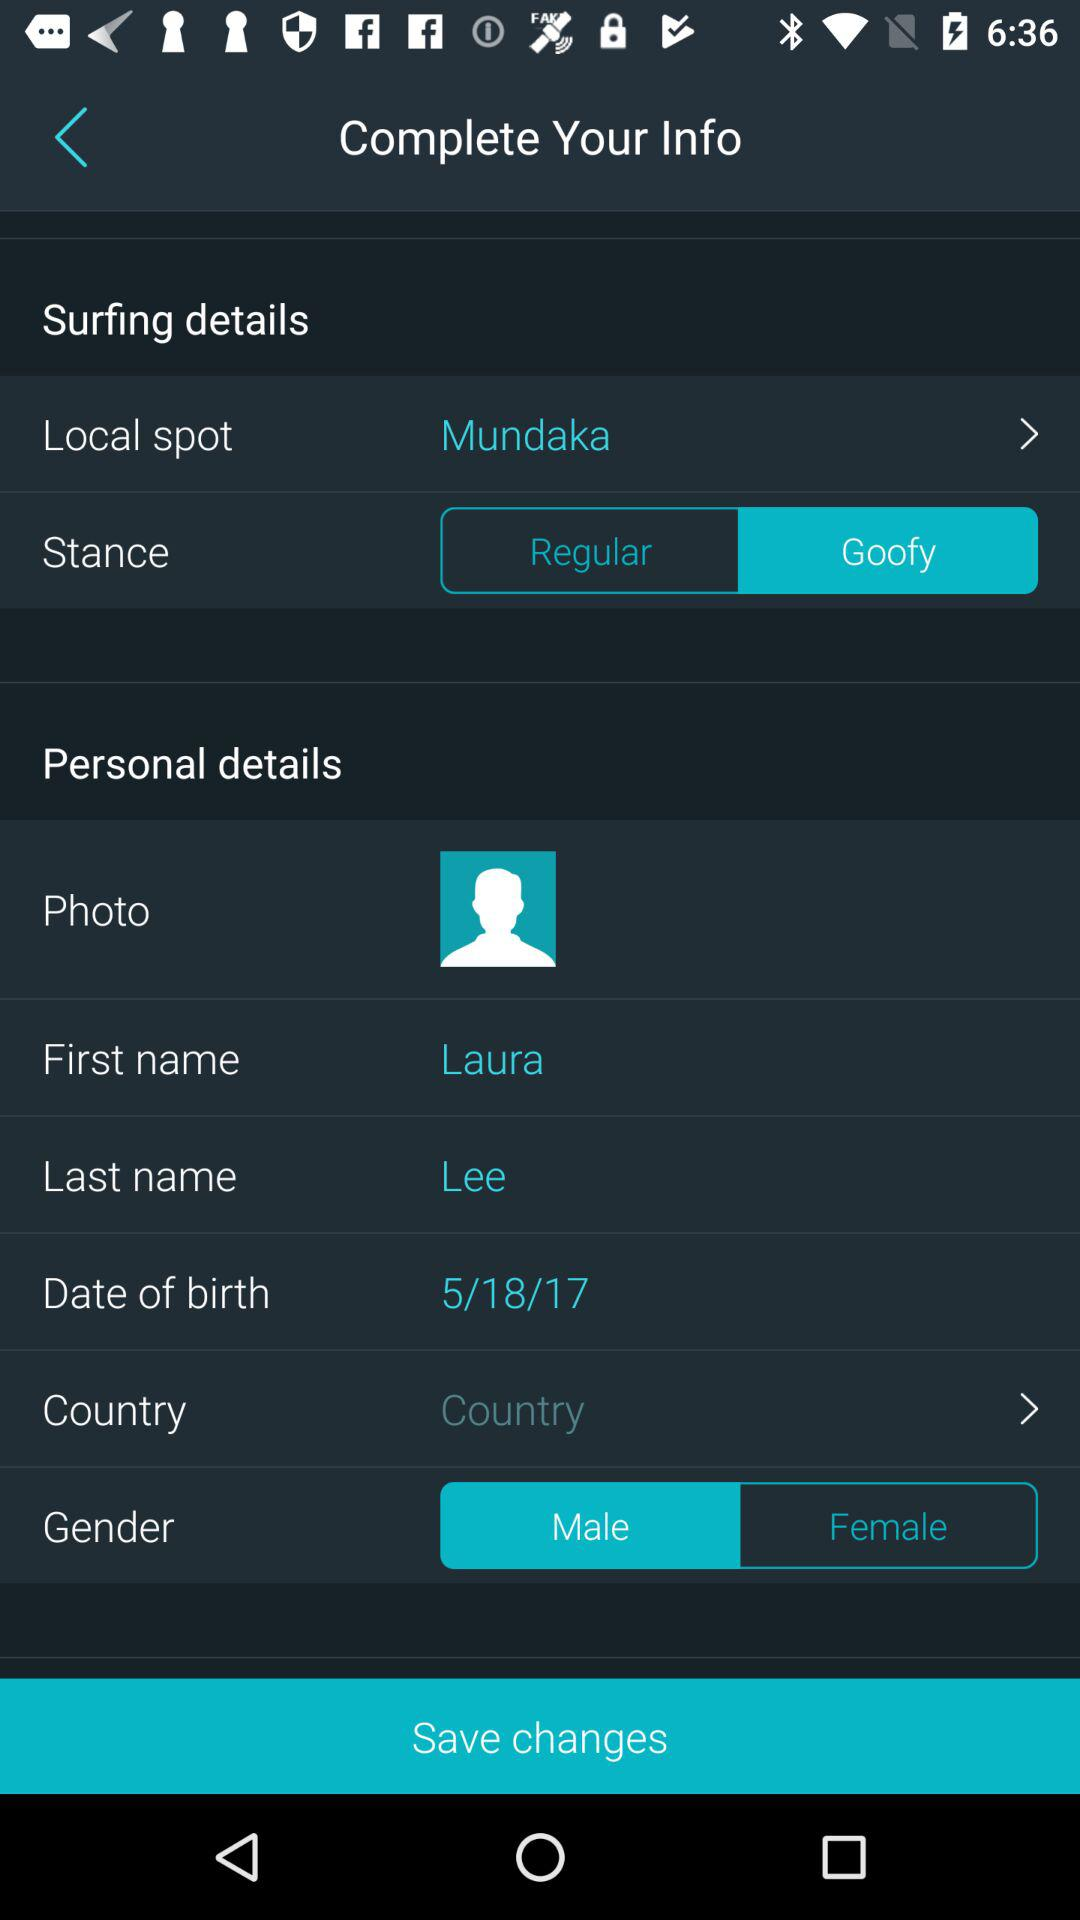What is the last name? The last name is "Lee". 